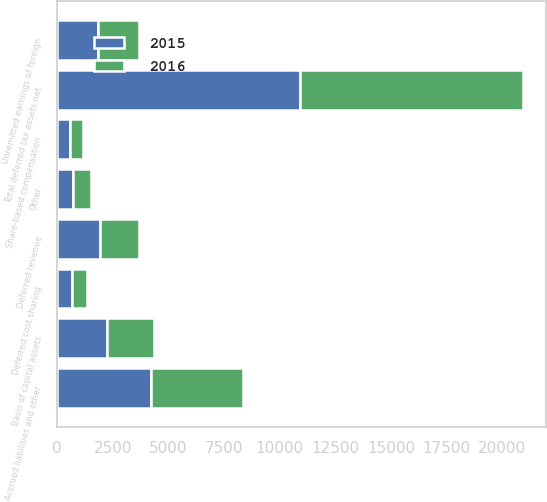Convert chart to OTSL. <chart><loc_0><loc_0><loc_500><loc_500><stacked_bar_chart><ecel><fcel>Accrued liabilities and other<fcel>Basis of capital assets<fcel>Deferred revenue<fcel>Deferred cost sharing<fcel>Share-based compensation<fcel>Other<fcel>Total deferred tax assets net<fcel>Unremitted earnings of foreign<nl><fcel>2016<fcel>4135<fcel>2107<fcel>1717<fcel>667<fcel>601<fcel>788<fcel>10015<fcel>1829<nl><fcel>2015<fcel>4205<fcel>2238<fcel>1941<fcel>667<fcel>575<fcel>721<fcel>10911<fcel>1829<nl></chart> 